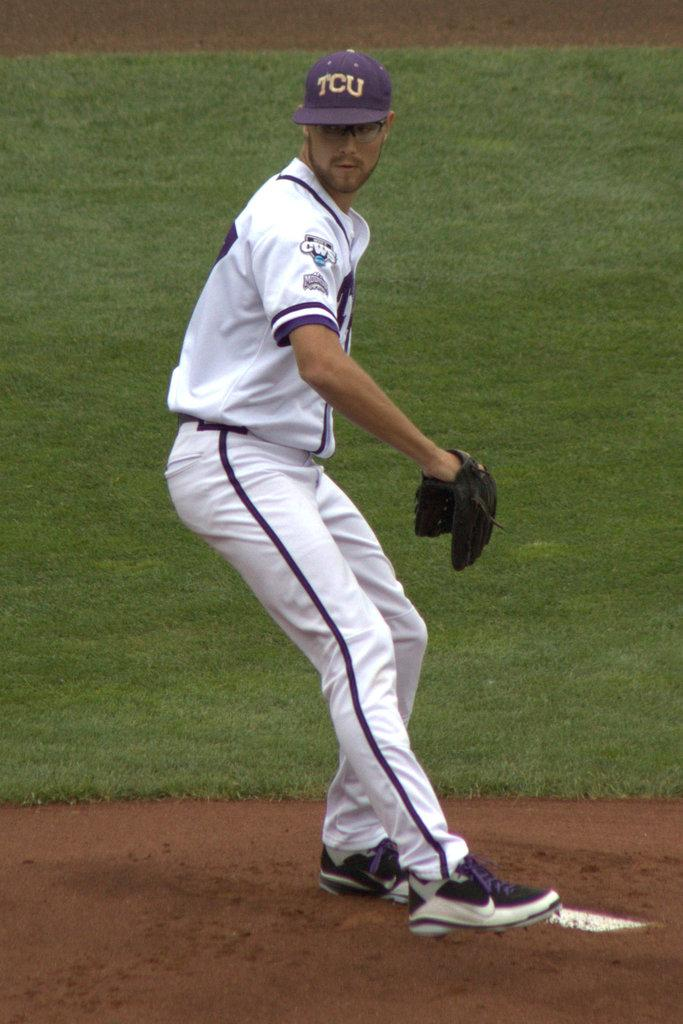<image>
Render a clear and concise summary of the photo. a pitcher on the mound with TCU on his baseball cap 